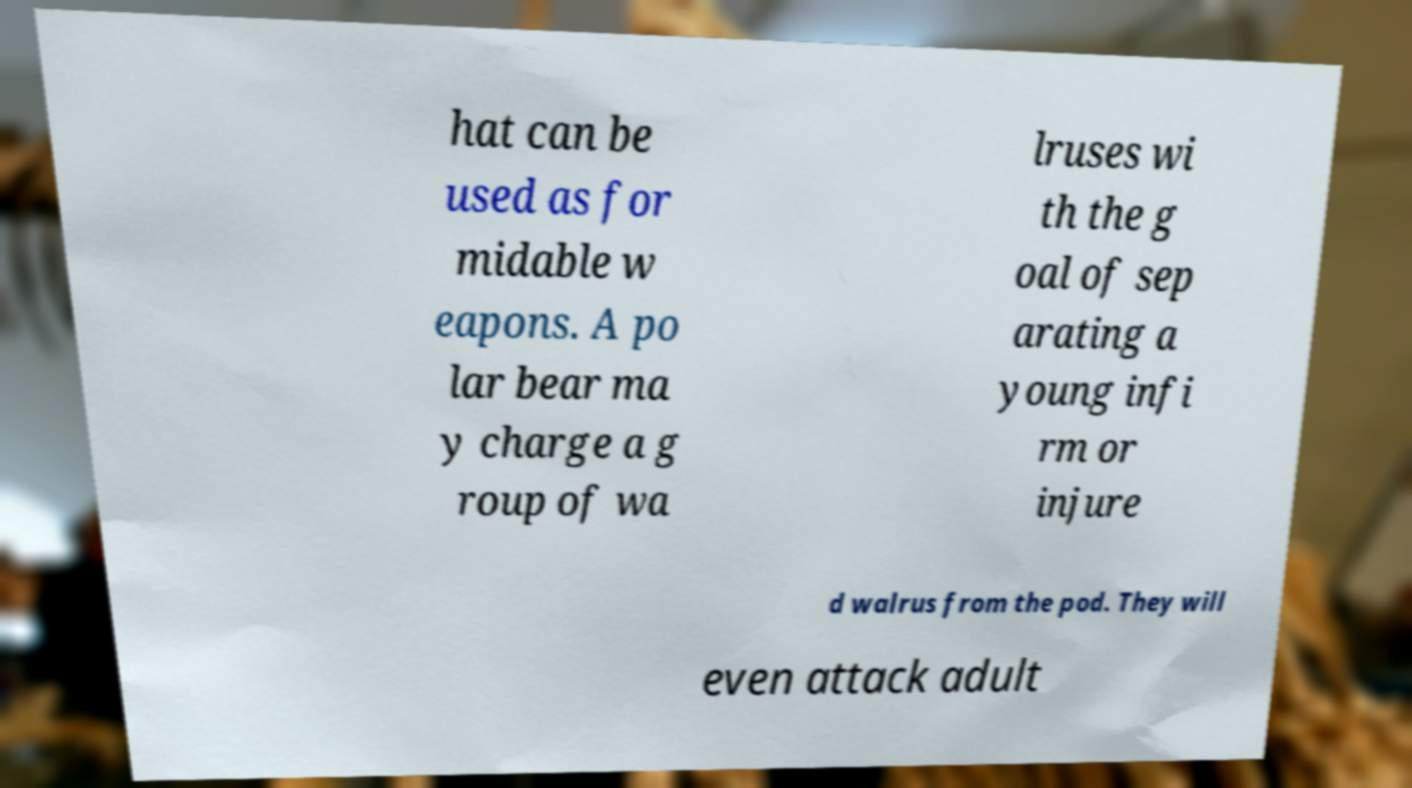I need the written content from this picture converted into text. Can you do that? hat can be used as for midable w eapons. A po lar bear ma y charge a g roup of wa lruses wi th the g oal of sep arating a young infi rm or injure d walrus from the pod. They will even attack adult 